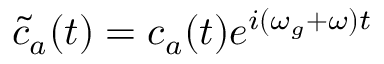<formula> <loc_0><loc_0><loc_500><loc_500>\tilde { c } _ { a } ( t ) = c _ { a } ( t ) e ^ { i ( \omega _ { g } + \omega ) t }</formula> 